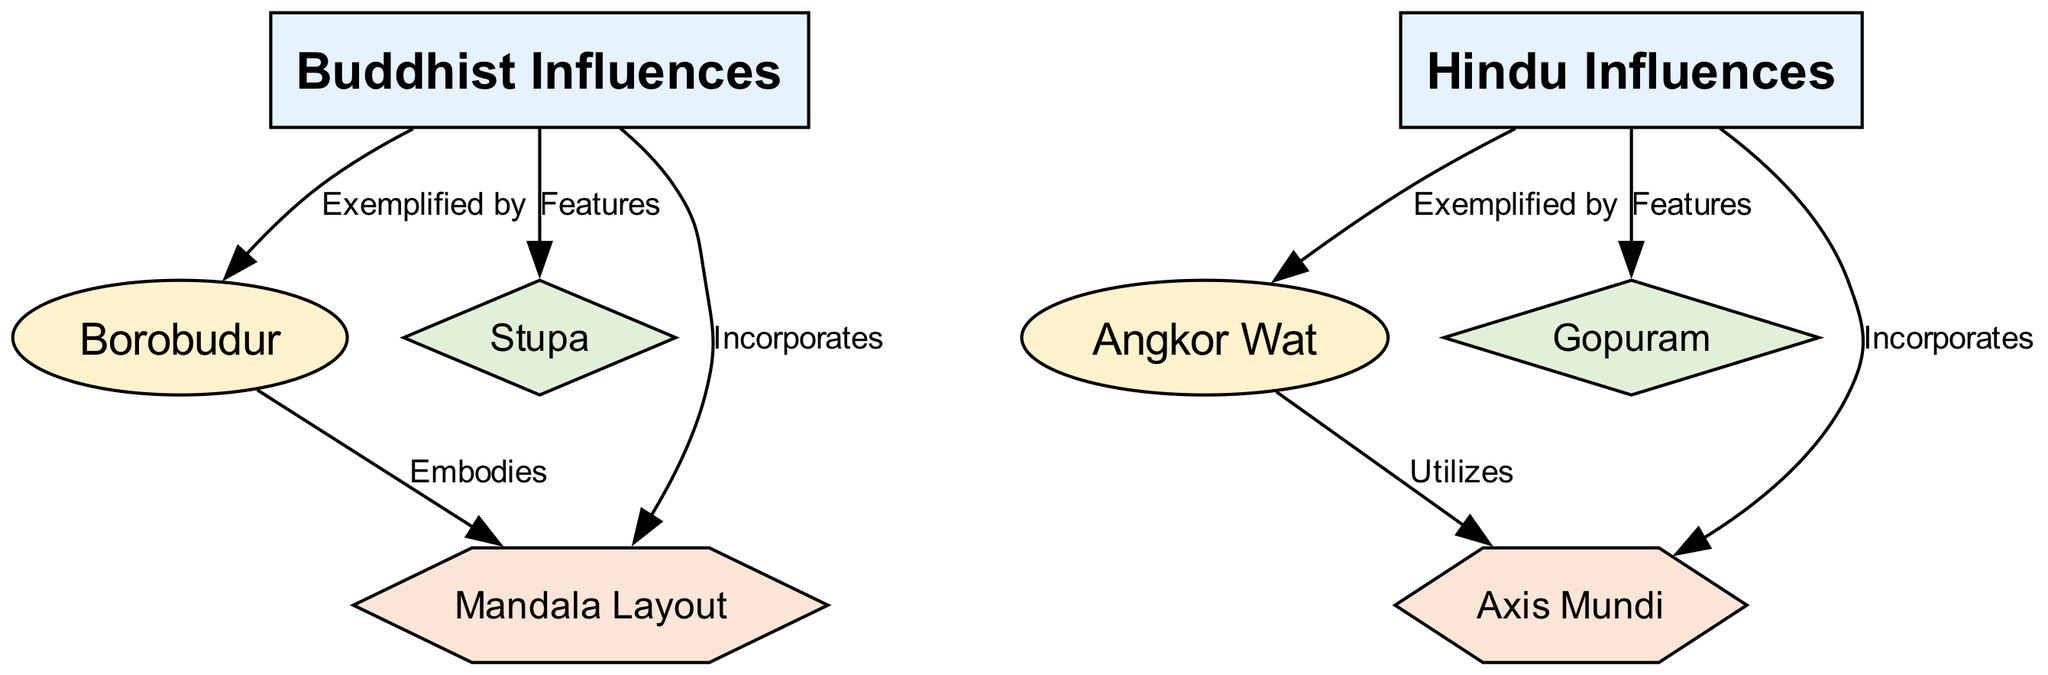What are the two major categories represented in the diagram? The diagram features nodes labeled "Buddhist Influences" and "Hindu Influences" as the two major categories, clearly marked in the respective sections of the graph.
Answer: Buddhist Influences, Hindu Influences How many architectural elements are featured in the diagram? The diagram includes two architectural elements identified as "Stupa" and "Gopuram." These are represented as diamonds in the visual structure of the graph.
Answer: 2 Which example is exemplified by Buddhist influences? The diagram shows that "Borobudur" is connected to "Buddhist Influences" with an edge labeled "Exemplified by," indicating that this example reflects Buddhist architectural styles.
Answer: Borobudur What urban planning concept incorporates Hindu influences? The diagram indicates that "Axis Mundi" is connected to "Hindu Influences" with an edge labeled "Incorporates," highlighting this concept's relevance to Hindu architectural planning.
Answer: Axis Mundi Which example utilizes the urban planning concept "Axis Mundi"? The diagram connects "Angkor Wat" to "Axis Mundi" with an edge labeled "Utilizes," indicating that Angkor Wat specifically applies this urban planning concept.
Answer: Angkor Wat Which architectural element features Buddhist influences? The diagram identifies "Stupa" as an architectural element under "Buddhist Influences," demonstrating its significance within Buddhist architecture as per the connection shown.
Answer: Stupa How are Borobudur and the Mandala Layout related in the diagram? The diagram has an edge from "Borobudur" to "Mandala Layout" labeled "Embodies," suggesting that Borobudur exemplifies or incorporates this urban planning concept in its design.
Answer: Embodies What is the total number of edges connecting the examples to the major categories? The diagram illustrates four unique connections (edges) linking the examples "Angkor Wat" and "Borobudur" to the major categories, allowing for a straightforward count.
Answer: 4 Which major category incorporates the urban planning concept "Mandala Layout"? The diagram clearly shows that "Mandala Layout" is connected to "Buddhist Influences" with an edge labeled "Incorporates," signifying its incorporation in Buddhist architecture.
Answer: Buddhist Influences 